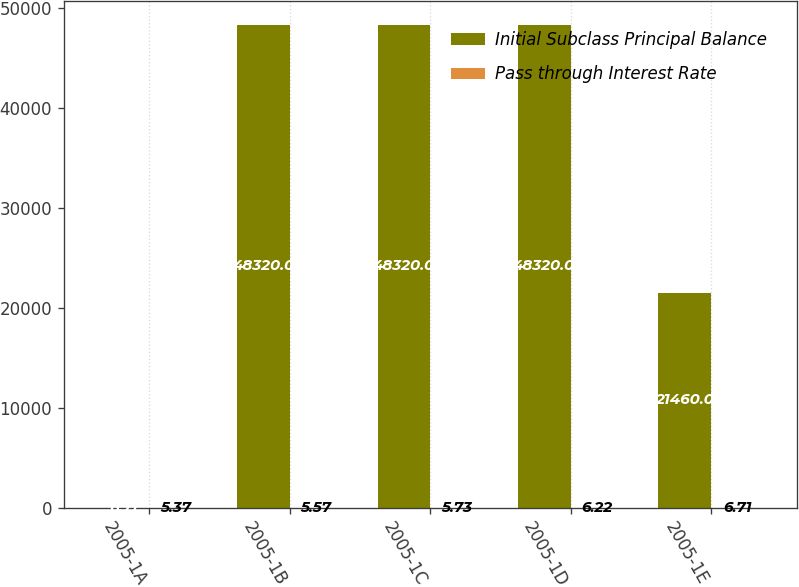Convert chart to OTSL. <chart><loc_0><loc_0><loc_500><loc_500><stacked_bar_chart><ecel><fcel>2005-1A<fcel>2005-1B<fcel>2005-1C<fcel>2005-1D<fcel>2005-1E<nl><fcel>Initial Subclass Principal Balance<fcel>6.71<fcel>48320<fcel>48320<fcel>48320<fcel>21460<nl><fcel>Pass through Interest Rate<fcel>5.37<fcel>5.57<fcel>5.73<fcel>6.22<fcel>6.71<nl></chart> 